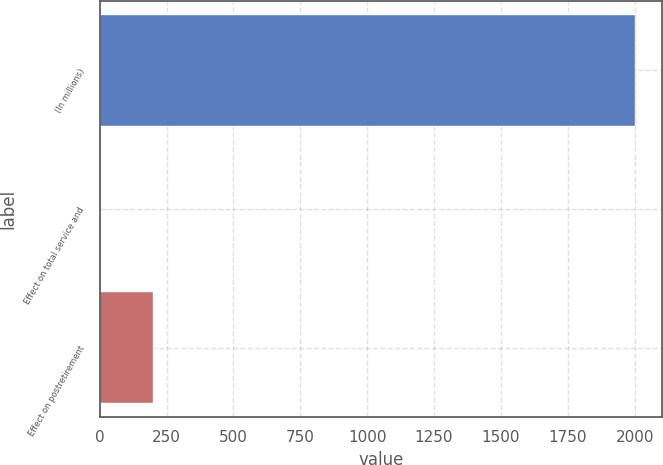Convert chart. <chart><loc_0><loc_0><loc_500><loc_500><bar_chart><fcel>(In millions)<fcel>Effect on total service and<fcel>Effect on postretirement<nl><fcel>2001<fcel>0.7<fcel>200.73<nl></chart> 